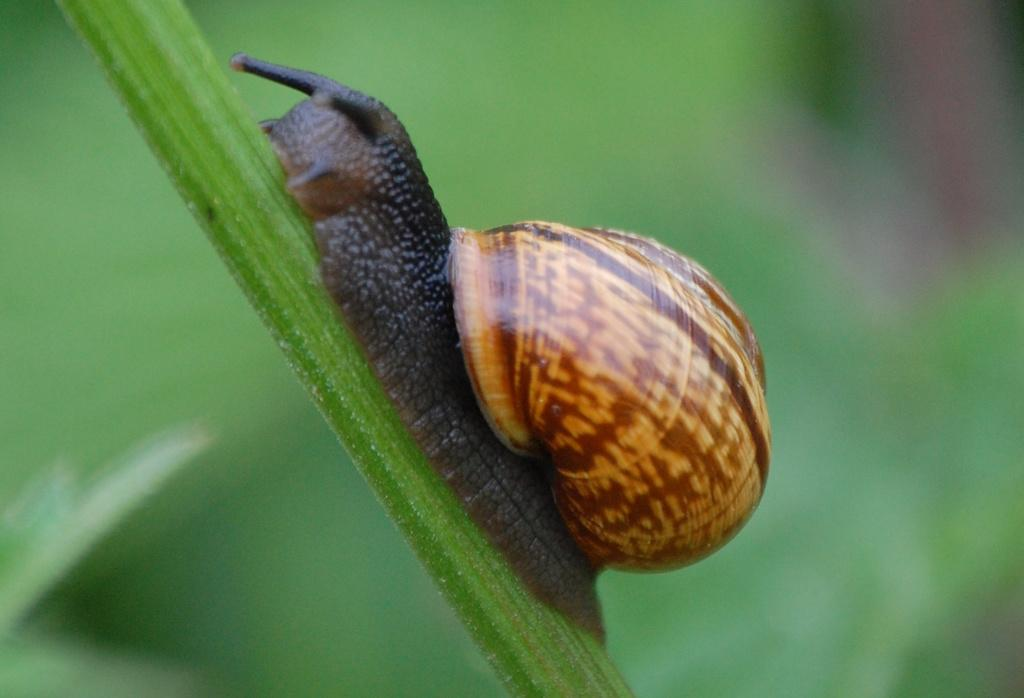What type of creature is present in the image? There is an animal in the image. What is the animal standing on or interacting with? The animal is on a green object. Can you describe the background of the image? The background of the image is blurred. What type of potato is being used to get the animal's attention in the image? There is no potato present in the image, and the animal's attention is not being sought. Can you tell me what hospital the animal is visiting in the image? There is no hospital present in the image, and the animal is not visiting any location. 